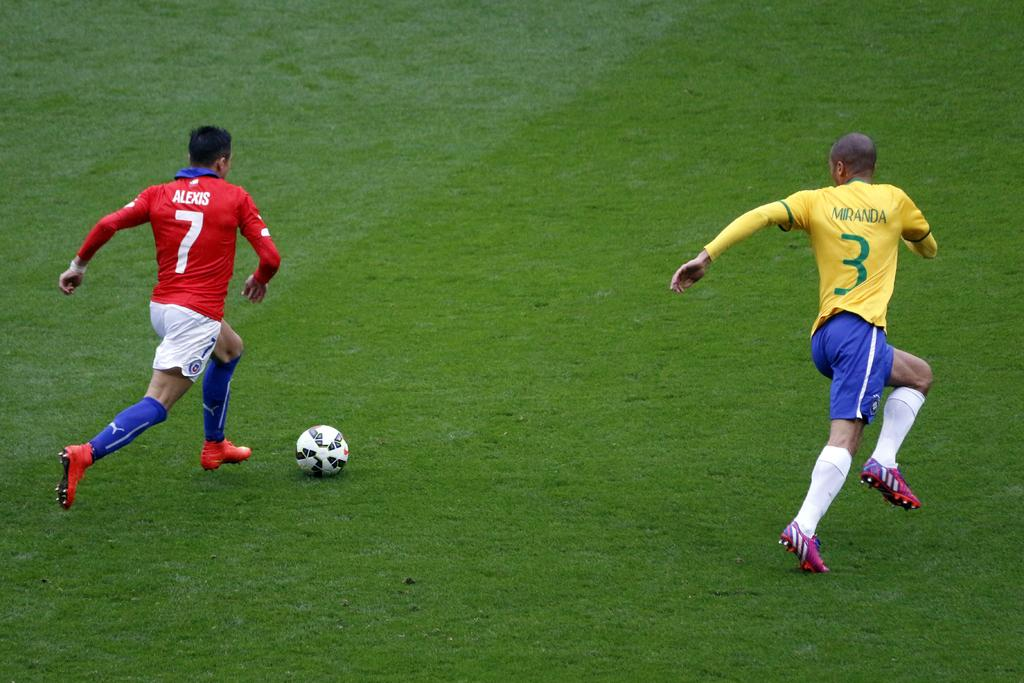Provide a one-sentence caption for the provided image. A soccer player with a red shirt with the number 7 and his name - Alexis printed on it and another soccer player with a yellow t-shirt. 